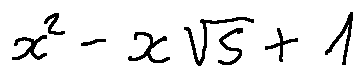<formula> <loc_0><loc_0><loc_500><loc_500>x ^ { 2 } - x \sqrt { 5 } + 1</formula> 